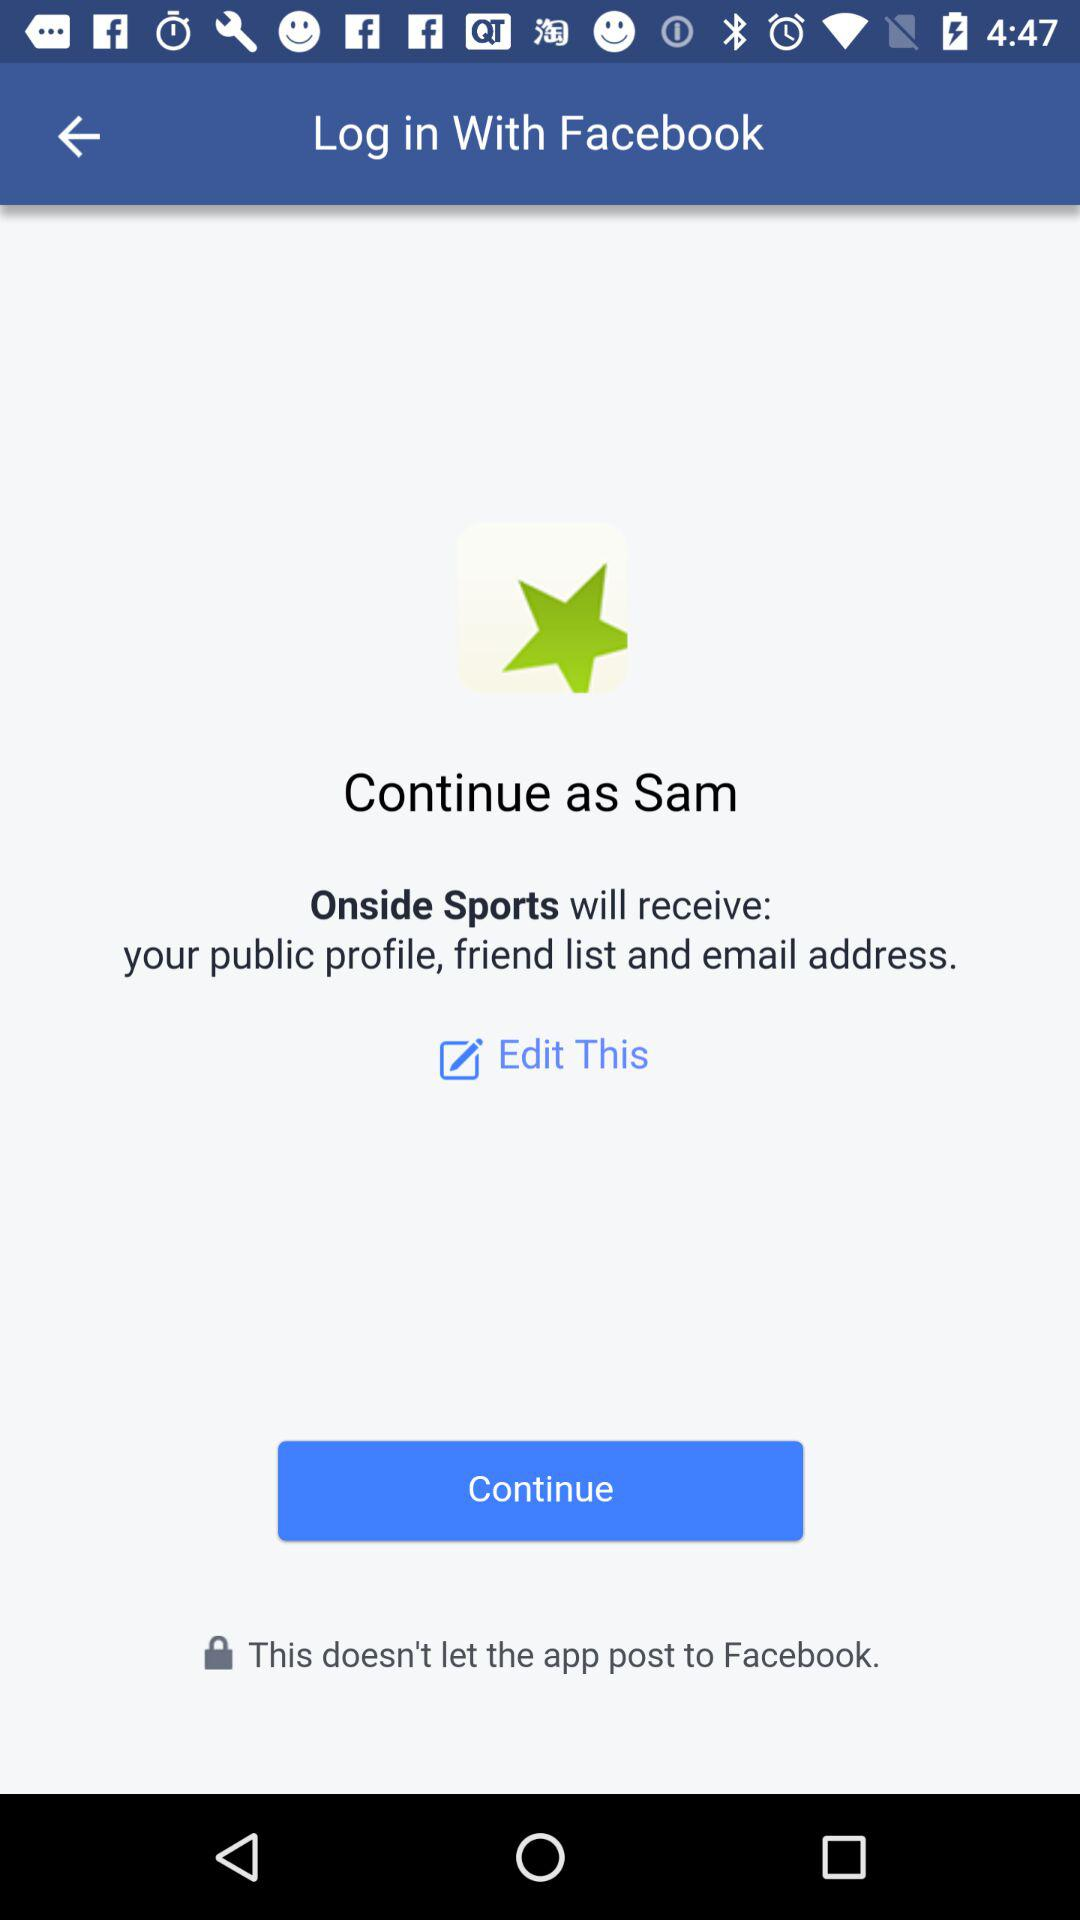What application is asking for permission? The application "Onside Sports" is asking for permission. 